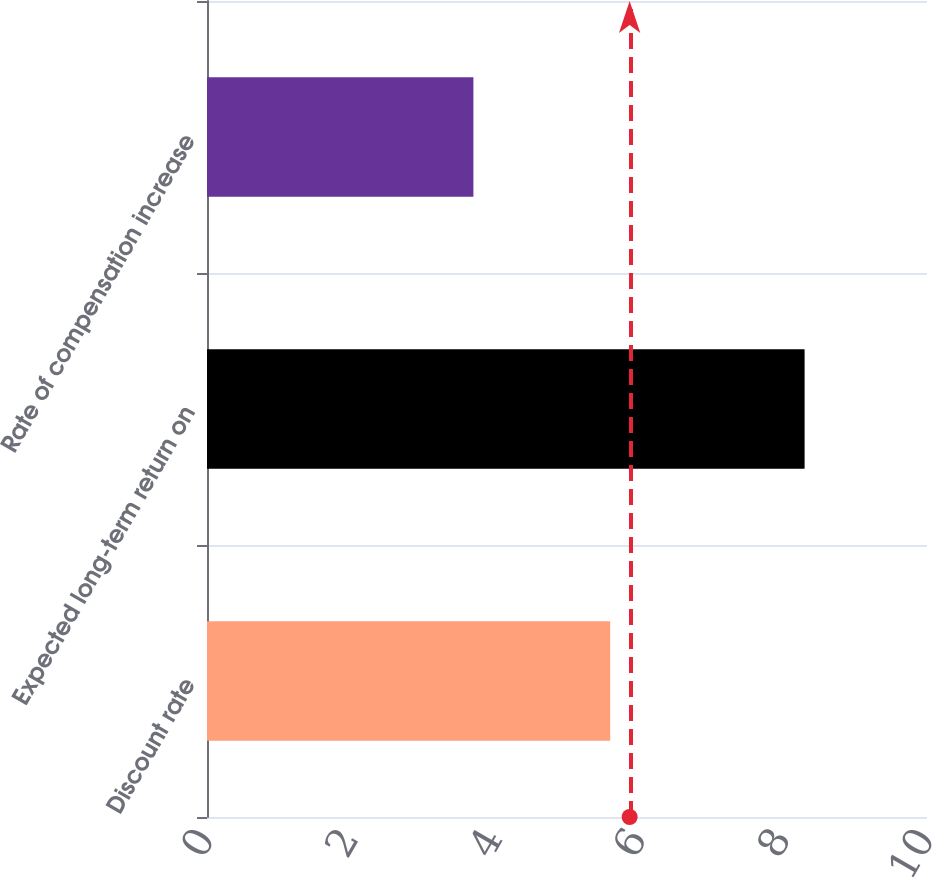Convert chart. <chart><loc_0><loc_0><loc_500><loc_500><bar_chart><fcel>Discount rate<fcel>Expected long-term return on<fcel>Rate of compensation increase<nl><fcel>5.6<fcel>8.3<fcel>3.7<nl></chart> 